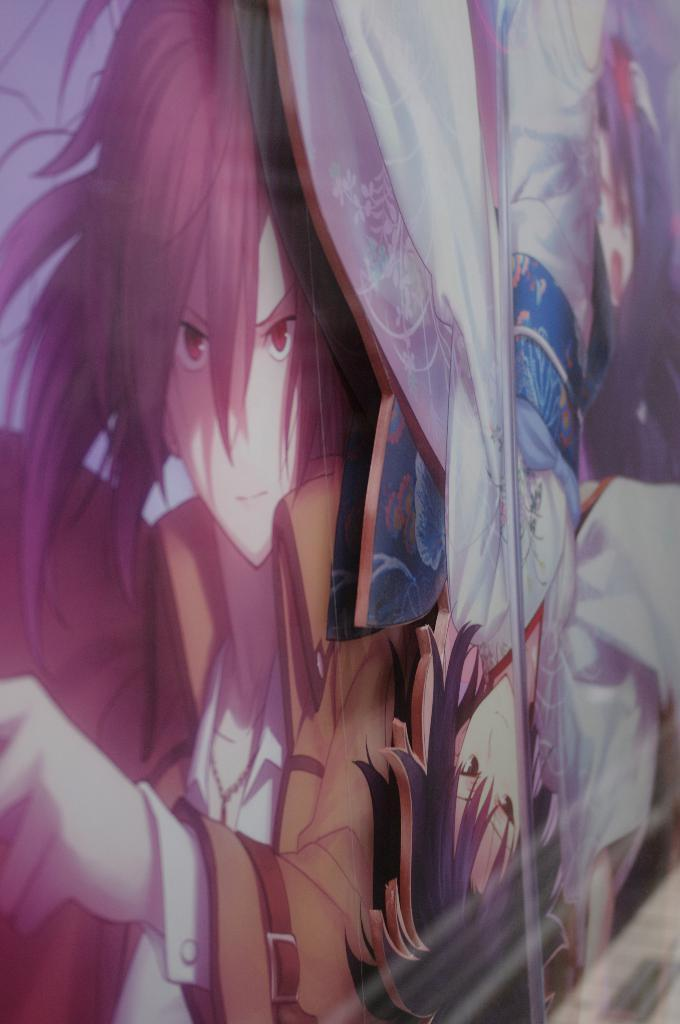What object is present in the image that is typically used for holding liquids? There is a glass in the image. What type of image can be seen in the glass? There is a cartoon image of two people in the image. How much payment is required to pull the truck in the image? There is no truck or payment mentioned in the image; it only features a glass and a cartoon image of two people. 